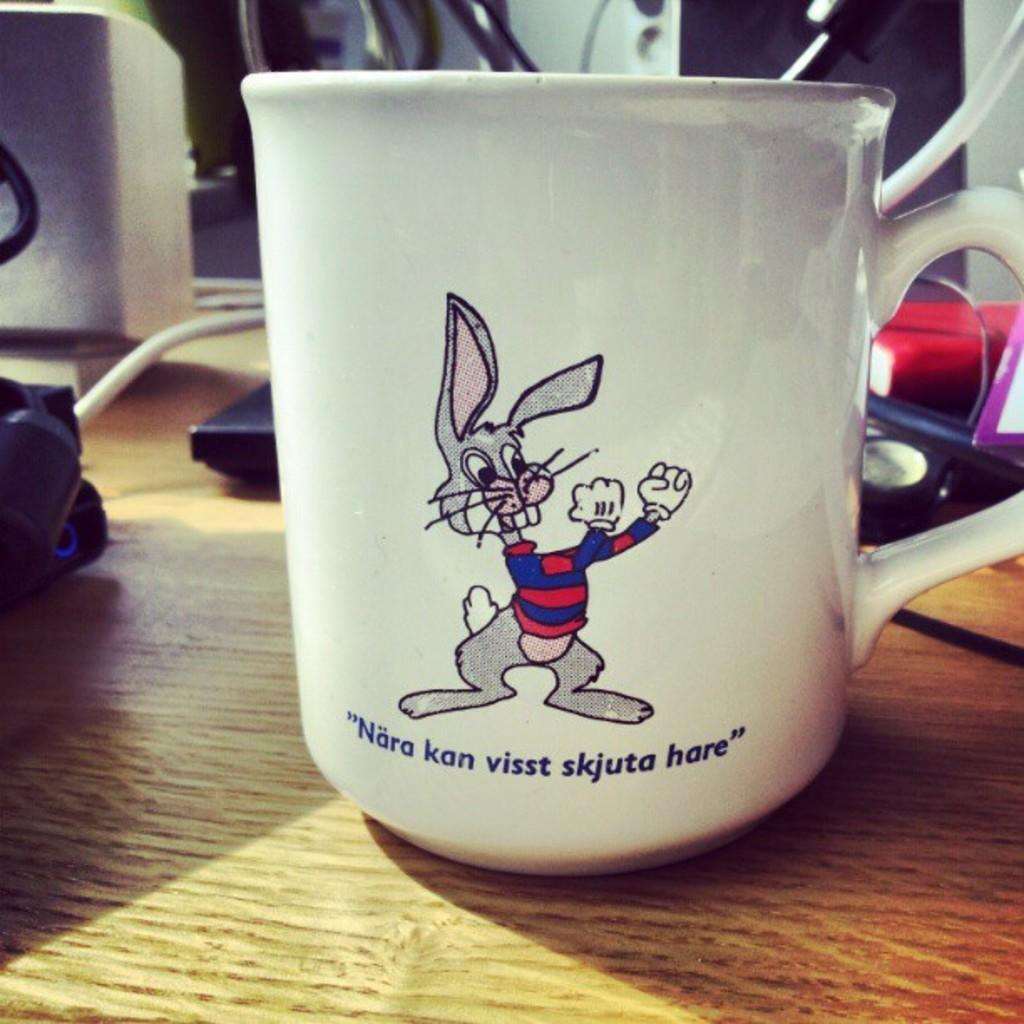<image>
Share a concise interpretation of the image provided. A bunny on a mug saying Nara kan visst skjuta hare. 